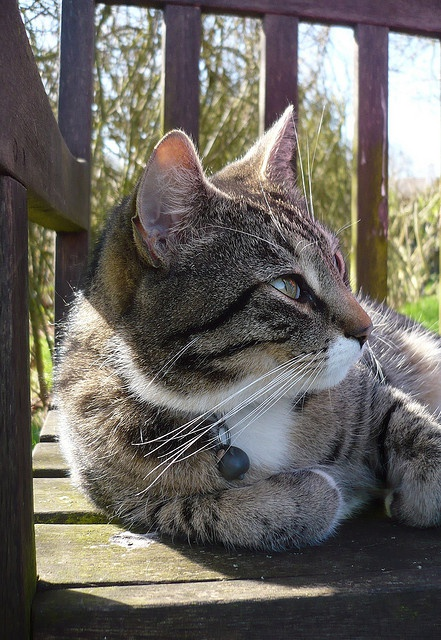Describe the objects in this image and their specific colors. I can see cat in black, gray, darkgray, and lightgray tones and bench in black, tan, and ivory tones in this image. 